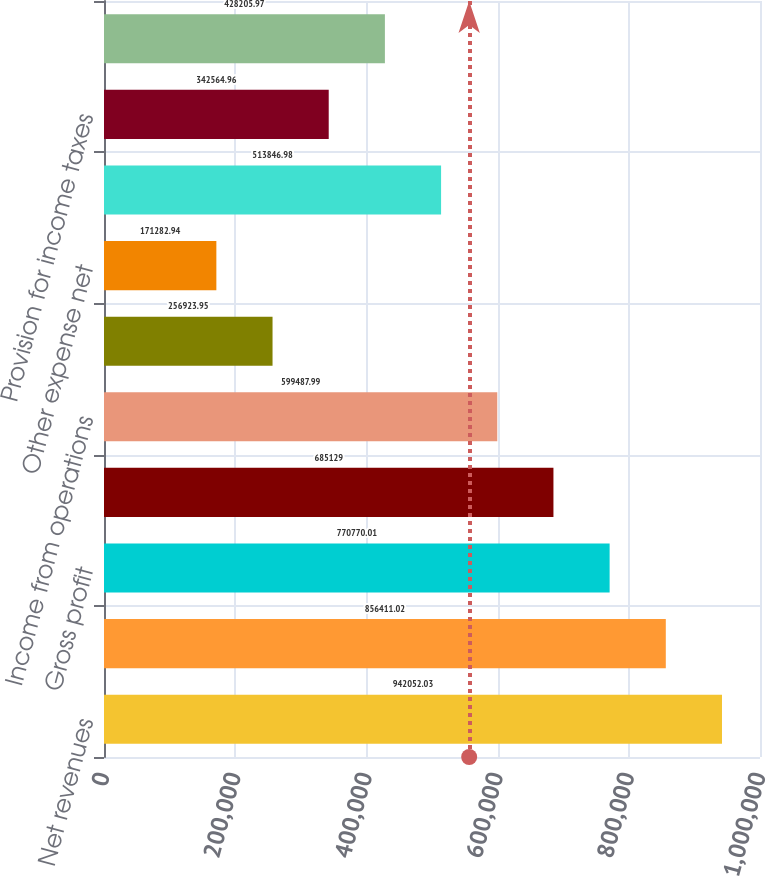<chart> <loc_0><loc_0><loc_500><loc_500><bar_chart><fcel>Net revenues<fcel>Cost of goods sold<fcel>Gross profit<fcel>Selling general and<fcel>Income from operations<fcel>Interest expense net<fcel>Other expense net<fcel>Income before income taxes<fcel>Provision for income taxes<fcel>Net income<nl><fcel>942052<fcel>856411<fcel>770770<fcel>685129<fcel>599488<fcel>256924<fcel>171283<fcel>513847<fcel>342565<fcel>428206<nl></chart> 